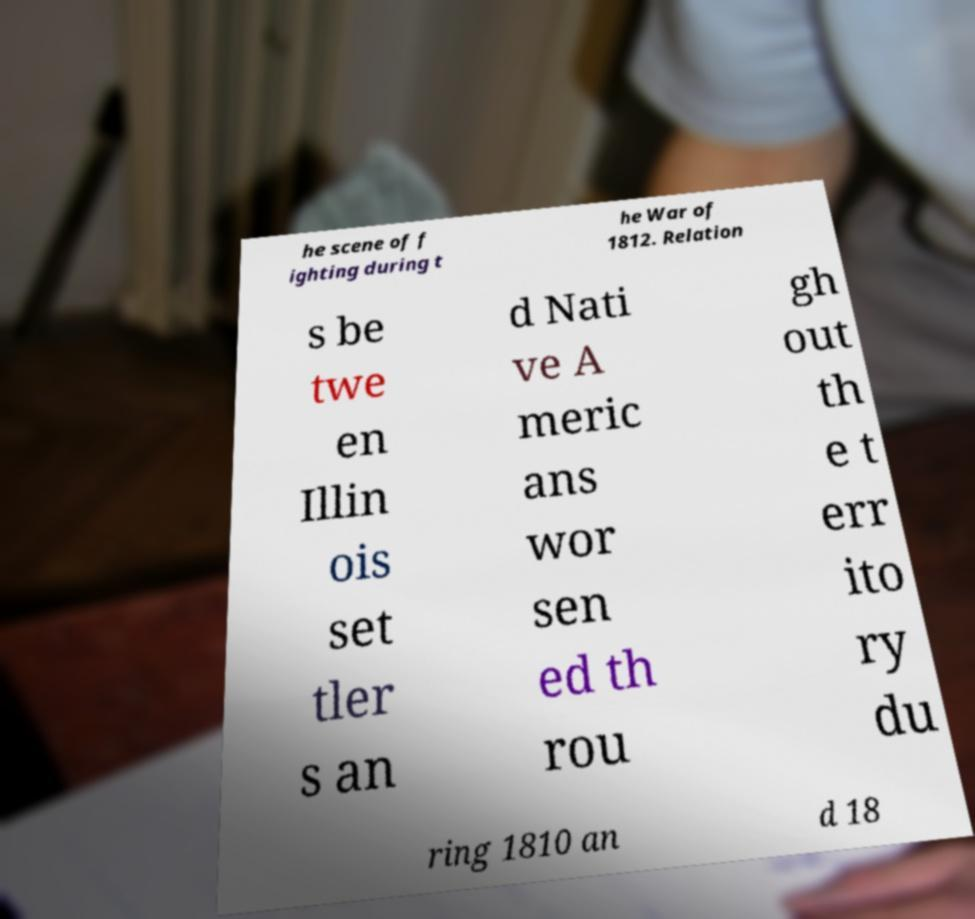I need the written content from this picture converted into text. Can you do that? he scene of f ighting during t he War of 1812. Relation s be twe en Illin ois set tler s an d Nati ve A meric ans wor sen ed th rou gh out th e t err ito ry du ring 1810 an d 18 